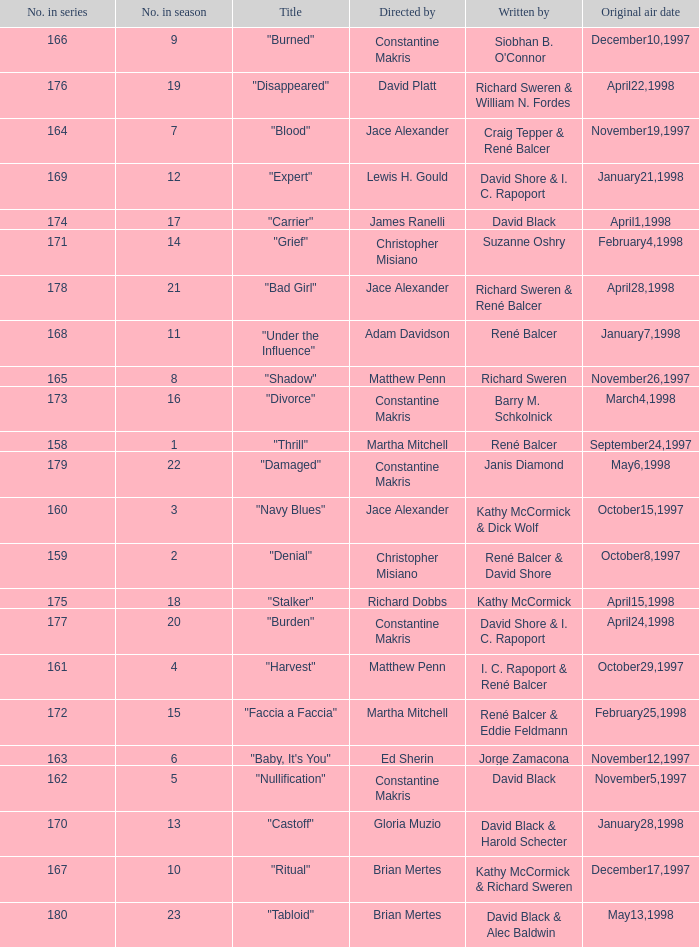Name the title of the episode that ed sherin directed. "Baby, It's You". 